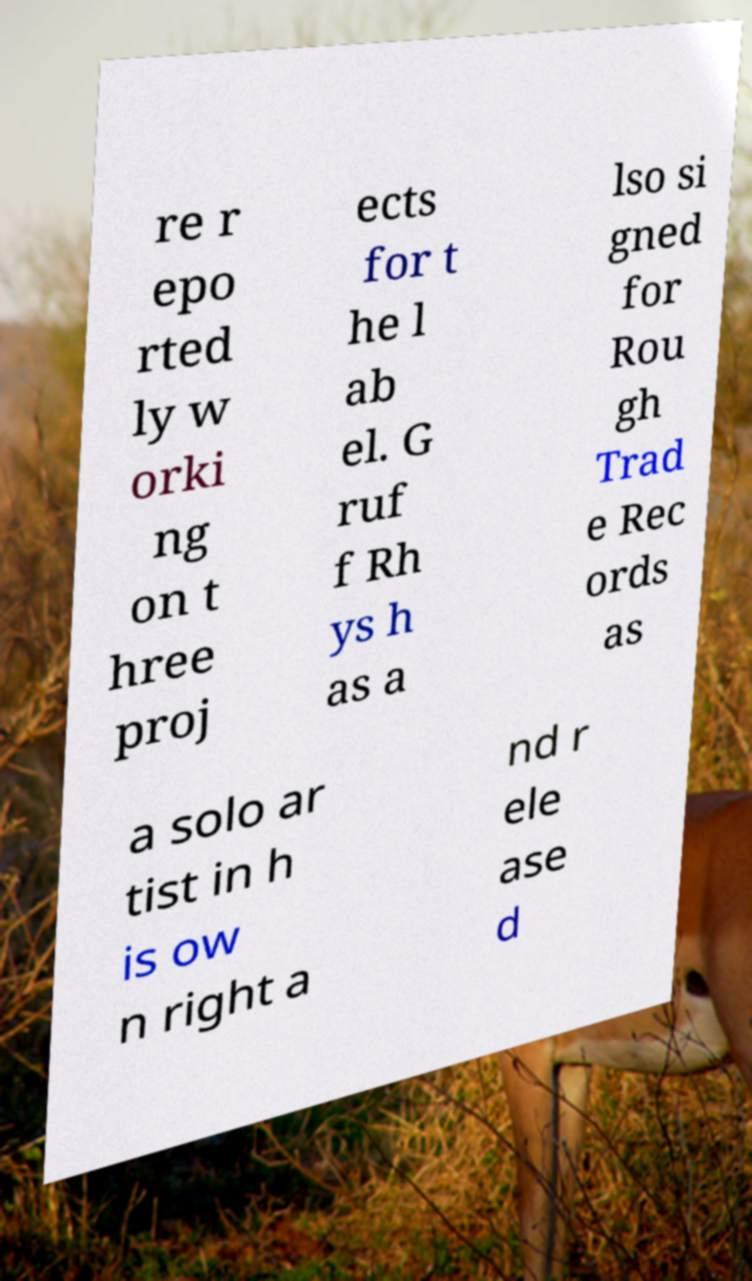Please read and relay the text visible in this image. What does it say? re r epo rted ly w orki ng on t hree proj ects for t he l ab el. G ruf f Rh ys h as a lso si gned for Rou gh Trad e Rec ords as a solo ar tist in h is ow n right a nd r ele ase d 